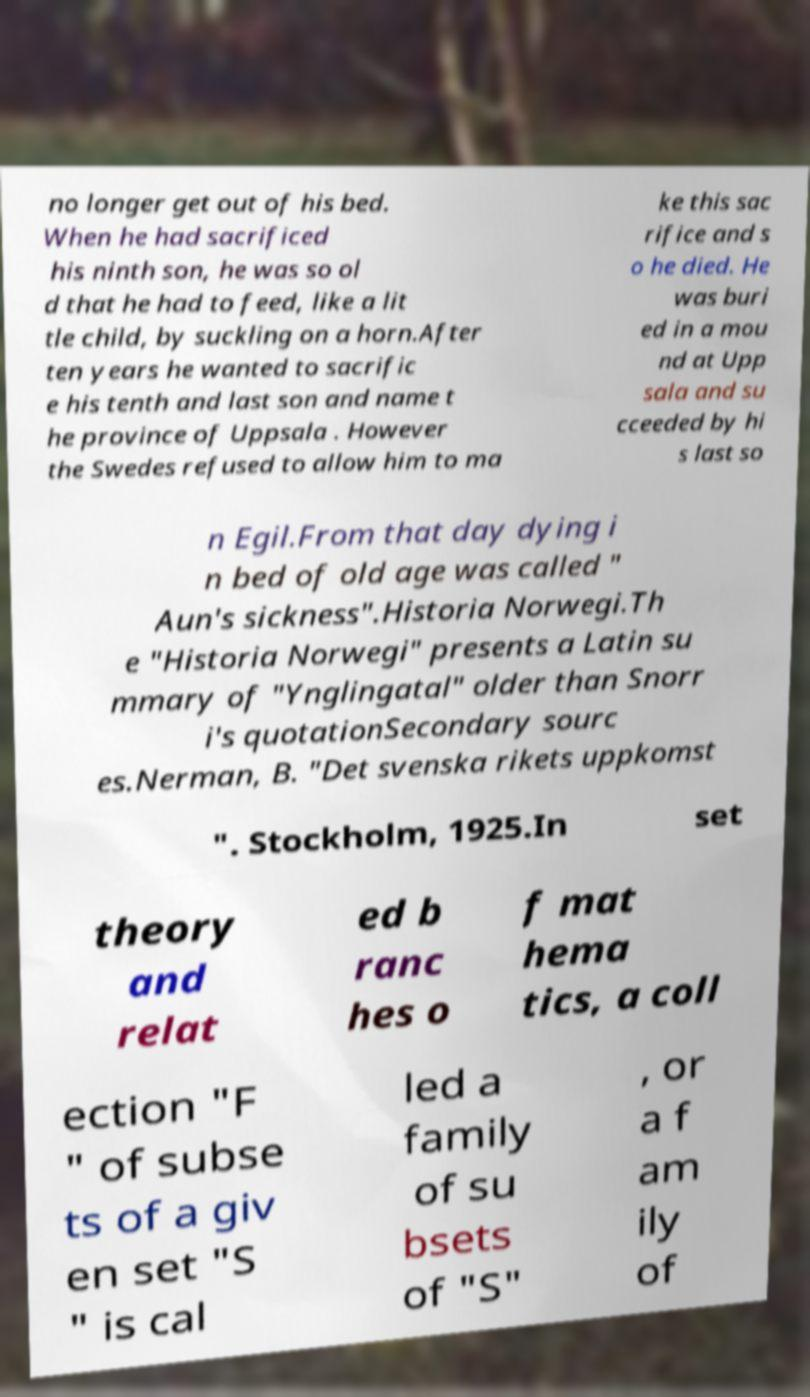Please read and relay the text visible in this image. What does it say? no longer get out of his bed. When he had sacrificed his ninth son, he was so ol d that he had to feed, like a lit tle child, by suckling on a horn.After ten years he wanted to sacrific e his tenth and last son and name t he province of Uppsala . However the Swedes refused to allow him to ma ke this sac rifice and s o he died. He was buri ed in a mou nd at Upp sala and su cceeded by hi s last so n Egil.From that day dying i n bed of old age was called " Aun's sickness".Historia Norwegi.Th e "Historia Norwegi" presents a Latin su mmary of "Ynglingatal" older than Snorr i's quotationSecondary sourc es.Nerman, B. "Det svenska rikets uppkomst ". Stockholm, 1925.In set theory and relat ed b ranc hes o f mat hema tics, a coll ection "F " of subse ts of a giv en set "S " is cal led a family of su bsets of "S" , or a f am ily of 